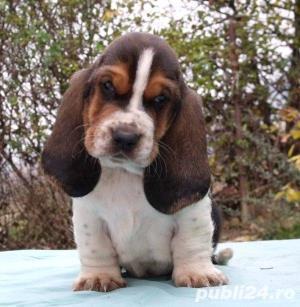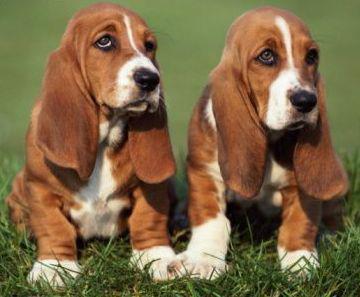The first image is the image on the left, the second image is the image on the right. Assess this claim about the two images: "The dogs in the image on the right are outside in the grass.". Correct or not? Answer yes or no. Yes. The first image is the image on the left, the second image is the image on the right. Evaluate the accuracy of this statement regarding the images: "One image shows a large basset hound on green grass, with at least one smaller hound touching it, and the other image features exactly two hounds side-by-side.". Is it true? Answer yes or no. No. 